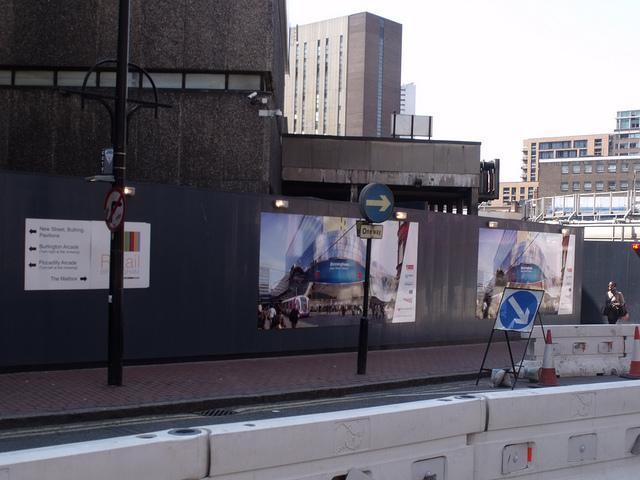What are the blue signs being used for? Please explain your reasoning. directing traffic. They have arrows to show drivers and pedestrians where to go. 